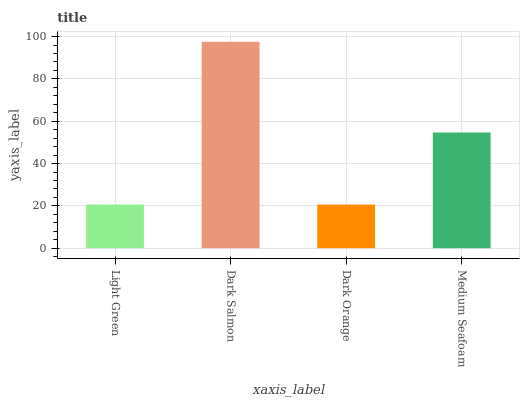Is Dark Orange the minimum?
Answer yes or no. Yes. Is Dark Salmon the maximum?
Answer yes or no. Yes. Is Dark Salmon the minimum?
Answer yes or no. No. Is Dark Orange the maximum?
Answer yes or no. No. Is Dark Salmon greater than Dark Orange?
Answer yes or no. Yes. Is Dark Orange less than Dark Salmon?
Answer yes or no. Yes. Is Dark Orange greater than Dark Salmon?
Answer yes or no. No. Is Dark Salmon less than Dark Orange?
Answer yes or no. No. Is Medium Seafoam the high median?
Answer yes or no. Yes. Is Light Green the low median?
Answer yes or no. Yes. Is Light Green the high median?
Answer yes or no. No. Is Medium Seafoam the low median?
Answer yes or no. No. 